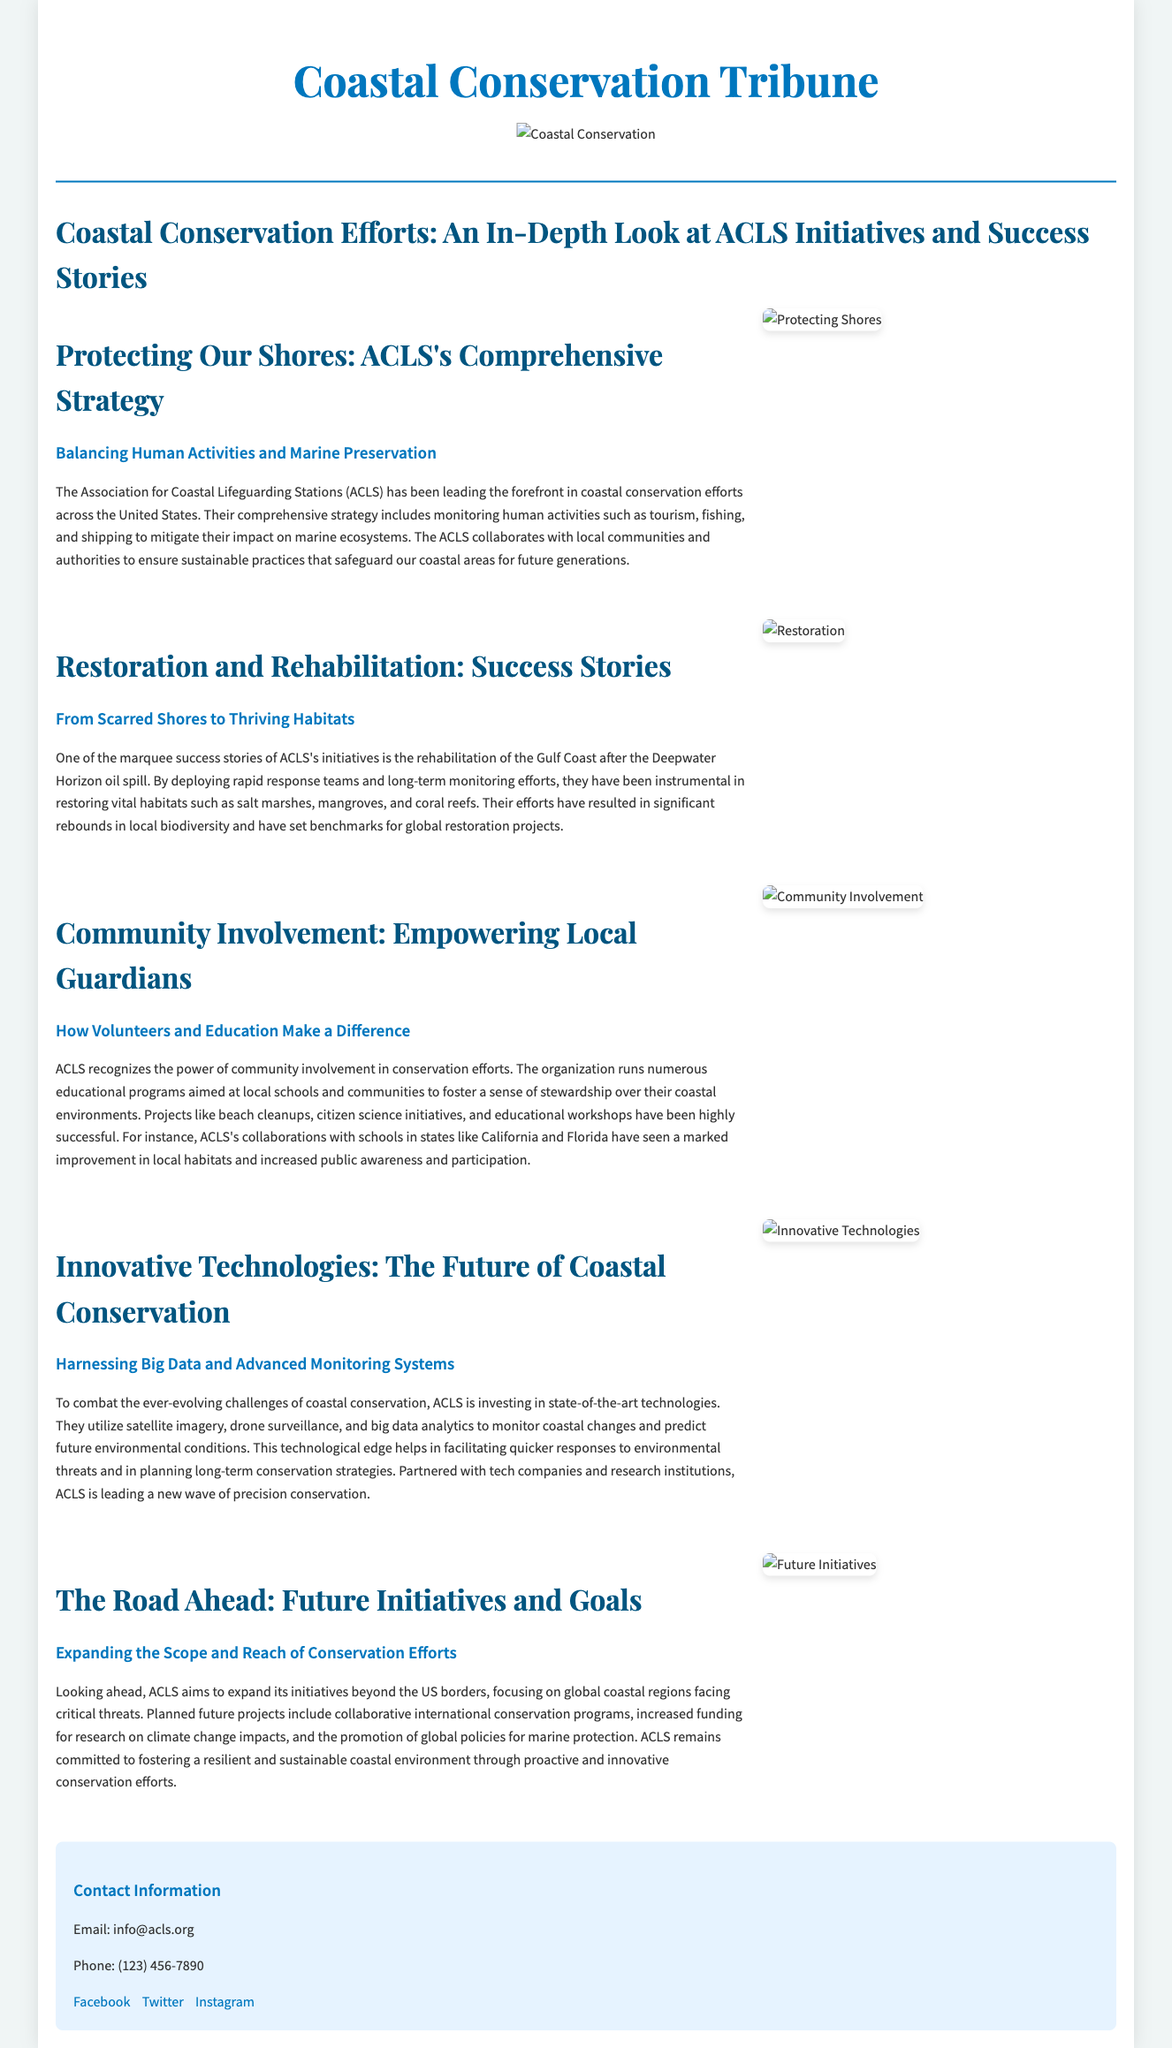What is the title of the article? The title of the article is mentioned prominently at the beginning of the document.
Answer: Coastal Conservation Efforts: An In-Depth Look at ACLS Initiatives and Success Stories Which organization is leading coastal conservation efforts? The organization that leads these efforts is stated repeatedly in the document.
Answer: Association for Coastal Lifeguarding Stations (ACLS) What major environmental disaster is referenced in the success stories? The document mentions a specific environmental disaster that ACLS responded to as a significant event.
Answer: Deepwater Horizon oil spill What technology does ACLS utilize for monitoring coastal changes? The document discusses the types of technologies used by ACLS for environmental monitoring.
Answer: Satellite imagery, drone surveillance, and big data analytics What is one specific community involvement project mentioned? The article lists examples of community engagement initiatives organized by ACLS.
Answer: Beach cleanups How does ACLS plan to expand its conservation initiatives? The document details the future plans of ACLS in terms of geographical and operational reach.
Answer: Beyond the US borders What is emphasized as vital for restoring habitats? The document highlights specific actions that are crucial for the restoration of coastal environments.
Answer: Long-term monitoring efforts What color is the heading of the document? The document's styles provide a specific color for the header text.
Answer: Blue 